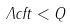<formula> <loc_0><loc_0><loc_500><loc_500>\Lambda c f t < Q</formula> 